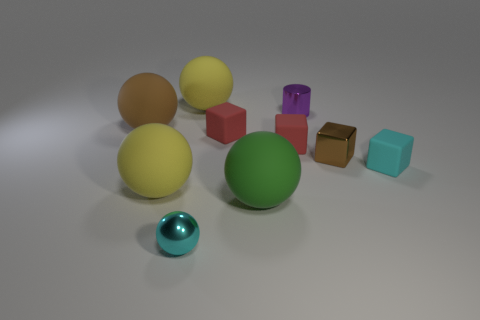Subtract all green spheres. How many spheres are left? 4 Subtract all big brown balls. How many balls are left? 4 Subtract all gray cubes. Subtract all purple balls. How many cubes are left? 4 Subtract all cylinders. How many objects are left? 9 Subtract 1 brown cubes. How many objects are left? 9 Subtract all small cyan matte blocks. Subtract all brown rubber cylinders. How many objects are left? 9 Add 9 green matte spheres. How many green matte spheres are left? 10 Add 3 purple cylinders. How many purple cylinders exist? 4 